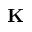<formula> <loc_0><loc_0><loc_500><loc_500>K</formula> 